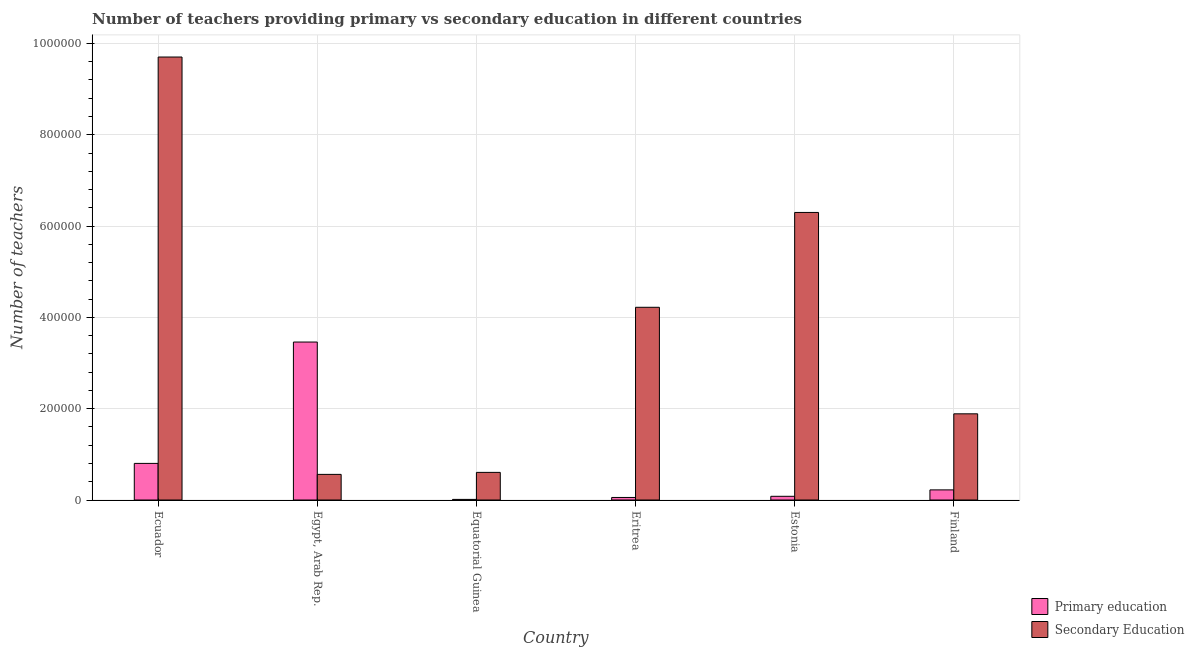How many different coloured bars are there?
Offer a very short reply. 2. How many groups of bars are there?
Keep it short and to the point. 6. How many bars are there on the 2nd tick from the left?
Your answer should be compact. 2. How many bars are there on the 6th tick from the right?
Provide a succinct answer. 2. What is the label of the 3rd group of bars from the left?
Your answer should be compact. Equatorial Guinea. What is the number of primary teachers in Finland?
Provide a succinct answer. 2.22e+04. Across all countries, what is the maximum number of primary teachers?
Provide a short and direct response. 3.46e+05. Across all countries, what is the minimum number of secondary teachers?
Provide a succinct answer. 5.61e+04. In which country was the number of secondary teachers maximum?
Give a very brief answer. Ecuador. In which country was the number of secondary teachers minimum?
Offer a very short reply. Egypt, Arab Rep. What is the total number of secondary teachers in the graph?
Provide a succinct answer. 2.33e+06. What is the difference between the number of secondary teachers in Egypt, Arab Rep. and that in Eritrea?
Give a very brief answer. -3.66e+05. What is the difference between the number of secondary teachers in Ecuador and the number of primary teachers in Equatorial Guinea?
Make the answer very short. 9.69e+05. What is the average number of primary teachers per country?
Offer a terse response. 7.72e+04. What is the difference between the number of primary teachers and number of secondary teachers in Estonia?
Your answer should be compact. -6.22e+05. In how many countries, is the number of primary teachers greater than 640000 ?
Keep it short and to the point. 0. What is the ratio of the number of primary teachers in Equatorial Guinea to that in Eritrea?
Provide a short and direct response. 0.24. Is the difference between the number of secondary teachers in Estonia and Finland greater than the difference between the number of primary teachers in Estonia and Finland?
Offer a terse response. Yes. What is the difference between the highest and the second highest number of secondary teachers?
Provide a succinct answer. 3.40e+05. What is the difference between the highest and the lowest number of primary teachers?
Make the answer very short. 3.45e+05. Is the sum of the number of secondary teachers in Equatorial Guinea and Finland greater than the maximum number of primary teachers across all countries?
Provide a short and direct response. No. What does the 1st bar from the left in Egypt, Arab Rep. represents?
Keep it short and to the point. Primary education. What is the difference between two consecutive major ticks on the Y-axis?
Your answer should be compact. 2.00e+05. Are the values on the major ticks of Y-axis written in scientific E-notation?
Provide a succinct answer. No. Where does the legend appear in the graph?
Make the answer very short. Bottom right. What is the title of the graph?
Your answer should be compact. Number of teachers providing primary vs secondary education in different countries. Does "Depositors" appear as one of the legend labels in the graph?
Provide a short and direct response. No. What is the label or title of the Y-axis?
Offer a very short reply. Number of teachers. What is the Number of teachers in Primary education in Ecuador?
Offer a terse response. 8.02e+04. What is the Number of teachers of Secondary Education in Ecuador?
Your answer should be very brief. 9.70e+05. What is the Number of teachers of Primary education in Egypt, Arab Rep.?
Provide a succinct answer. 3.46e+05. What is the Number of teachers of Secondary Education in Egypt, Arab Rep.?
Offer a very short reply. 5.61e+04. What is the Number of teachers in Primary education in Equatorial Guinea?
Your answer should be very brief. 1322. What is the Number of teachers in Secondary Education in Equatorial Guinea?
Keep it short and to the point. 6.05e+04. What is the Number of teachers in Primary education in Eritrea?
Your response must be concise. 5576. What is the Number of teachers in Secondary Education in Eritrea?
Your answer should be compact. 4.22e+05. What is the Number of teachers of Primary education in Estonia?
Provide a succinct answer. 8086. What is the Number of teachers in Secondary Education in Estonia?
Keep it short and to the point. 6.30e+05. What is the Number of teachers in Primary education in Finland?
Make the answer very short. 2.22e+04. What is the Number of teachers in Secondary Education in Finland?
Offer a very short reply. 1.89e+05. Across all countries, what is the maximum Number of teachers in Primary education?
Your answer should be compact. 3.46e+05. Across all countries, what is the maximum Number of teachers of Secondary Education?
Your answer should be very brief. 9.70e+05. Across all countries, what is the minimum Number of teachers of Primary education?
Your answer should be compact. 1322. Across all countries, what is the minimum Number of teachers in Secondary Education?
Make the answer very short. 5.61e+04. What is the total Number of teachers of Primary education in the graph?
Your answer should be very brief. 4.63e+05. What is the total Number of teachers in Secondary Education in the graph?
Your answer should be compact. 2.33e+06. What is the difference between the Number of teachers of Primary education in Ecuador and that in Egypt, Arab Rep.?
Offer a terse response. -2.66e+05. What is the difference between the Number of teachers in Secondary Education in Ecuador and that in Egypt, Arab Rep.?
Your response must be concise. 9.14e+05. What is the difference between the Number of teachers in Primary education in Ecuador and that in Equatorial Guinea?
Your answer should be compact. 7.89e+04. What is the difference between the Number of teachers of Secondary Education in Ecuador and that in Equatorial Guinea?
Provide a short and direct response. 9.10e+05. What is the difference between the Number of teachers in Primary education in Ecuador and that in Eritrea?
Offer a very short reply. 7.46e+04. What is the difference between the Number of teachers of Secondary Education in Ecuador and that in Eritrea?
Your answer should be compact. 5.48e+05. What is the difference between the Number of teachers in Primary education in Ecuador and that in Estonia?
Ensure brevity in your answer.  7.21e+04. What is the difference between the Number of teachers of Secondary Education in Ecuador and that in Estonia?
Ensure brevity in your answer.  3.40e+05. What is the difference between the Number of teachers in Primary education in Ecuador and that in Finland?
Provide a succinct answer. 5.80e+04. What is the difference between the Number of teachers in Secondary Education in Ecuador and that in Finland?
Keep it short and to the point. 7.82e+05. What is the difference between the Number of teachers in Primary education in Egypt, Arab Rep. and that in Equatorial Guinea?
Your answer should be very brief. 3.45e+05. What is the difference between the Number of teachers in Secondary Education in Egypt, Arab Rep. and that in Equatorial Guinea?
Provide a succinct answer. -4373. What is the difference between the Number of teachers in Primary education in Egypt, Arab Rep. and that in Eritrea?
Your response must be concise. 3.40e+05. What is the difference between the Number of teachers of Secondary Education in Egypt, Arab Rep. and that in Eritrea?
Offer a very short reply. -3.66e+05. What is the difference between the Number of teachers in Primary education in Egypt, Arab Rep. and that in Estonia?
Make the answer very short. 3.38e+05. What is the difference between the Number of teachers in Secondary Education in Egypt, Arab Rep. and that in Estonia?
Your answer should be compact. -5.74e+05. What is the difference between the Number of teachers of Primary education in Egypt, Arab Rep. and that in Finland?
Offer a terse response. 3.24e+05. What is the difference between the Number of teachers of Secondary Education in Egypt, Arab Rep. and that in Finland?
Your answer should be very brief. -1.33e+05. What is the difference between the Number of teachers in Primary education in Equatorial Guinea and that in Eritrea?
Provide a short and direct response. -4254. What is the difference between the Number of teachers of Secondary Education in Equatorial Guinea and that in Eritrea?
Your answer should be very brief. -3.62e+05. What is the difference between the Number of teachers in Primary education in Equatorial Guinea and that in Estonia?
Ensure brevity in your answer.  -6764. What is the difference between the Number of teachers in Secondary Education in Equatorial Guinea and that in Estonia?
Keep it short and to the point. -5.69e+05. What is the difference between the Number of teachers of Primary education in Equatorial Guinea and that in Finland?
Keep it short and to the point. -2.08e+04. What is the difference between the Number of teachers of Secondary Education in Equatorial Guinea and that in Finland?
Your response must be concise. -1.28e+05. What is the difference between the Number of teachers in Primary education in Eritrea and that in Estonia?
Provide a succinct answer. -2510. What is the difference between the Number of teachers in Secondary Education in Eritrea and that in Estonia?
Offer a very short reply. -2.08e+05. What is the difference between the Number of teachers in Primary education in Eritrea and that in Finland?
Provide a succinct answer. -1.66e+04. What is the difference between the Number of teachers in Secondary Education in Eritrea and that in Finland?
Keep it short and to the point. 2.33e+05. What is the difference between the Number of teachers in Primary education in Estonia and that in Finland?
Provide a short and direct response. -1.41e+04. What is the difference between the Number of teachers of Secondary Education in Estonia and that in Finland?
Make the answer very short. 4.41e+05. What is the difference between the Number of teachers in Primary education in Ecuador and the Number of teachers in Secondary Education in Egypt, Arab Rep.?
Keep it short and to the point. 2.40e+04. What is the difference between the Number of teachers of Primary education in Ecuador and the Number of teachers of Secondary Education in Equatorial Guinea?
Your response must be concise. 1.97e+04. What is the difference between the Number of teachers in Primary education in Ecuador and the Number of teachers in Secondary Education in Eritrea?
Your answer should be compact. -3.42e+05. What is the difference between the Number of teachers in Primary education in Ecuador and the Number of teachers in Secondary Education in Estonia?
Offer a terse response. -5.50e+05. What is the difference between the Number of teachers of Primary education in Ecuador and the Number of teachers of Secondary Education in Finland?
Give a very brief answer. -1.09e+05. What is the difference between the Number of teachers in Primary education in Egypt, Arab Rep. and the Number of teachers in Secondary Education in Equatorial Guinea?
Your response must be concise. 2.85e+05. What is the difference between the Number of teachers in Primary education in Egypt, Arab Rep. and the Number of teachers in Secondary Education in Eritrea?
Offer a very short reply. -7.61e+04. What is the difference between the Number of teachers of Primary education in Egypt, Arab Rep. and the Number of teachers of Secondary Education in Estonia?
Make the answer very short. -2.84e+05. What is the difference between the Number of teachers of Primary education in Egypt, Arab Rep. and the Number of teachers of Secondary Education in Finland?
Your answer should be very brief. 1.57e+05. What is the difference between the Number of teachers of Primary education in Equatorial Guinea and the Number of teachers of Secondary Education in Eritrea?
Make the answer very short. -4.21e+05. What is the difference between the Number of teachers in Primary education in Equatorial Guinea and the Number of teachers in Secondary Education in Estonia?
Your response must be concise. -6.29e+05. What is the difference between the Number of teachers of Primary education in Equatorial Guinea and the Number of teachers of Secondary Education in Finland?
Keep it short and to the point. -1.87e+05. What is the difference between the Number of teachers of Primary education in Eritrea and the Number of teachers of Secondary Education in Estonia?
Keep it short and to the point. -6.24e+05. What is the difference between the Number of teachers in Primary education in Eritrea and the Number of teachers in Secondary Education in Finland?
Your answer should be compact. -1.83e+05. What is the difference between the Number of teachers of Primary education in Estonia and the Number of teachers of Secondary Education in Finland?
Make the answer very short. -1.81e+05. What is the average Number of teachers of Primary education per country?
Give a very brief answer. 7.72e+04. What is the average Number of teachers of Secondary Education per country?
Offer a very short reply. 3.88e+05. What is the difference between the Number of teachers in Primary education and Number of teachers in Secondary Education in Ecuador?
Your answer should be very brief. -8.90e+05. What is the difference between the Number of teachers in Primary education and Number of teachers in Secondary Education in Egypt, Arab Rep.?
Your answer should be very brief. 2.90e+05. What is the difference between the Number of teachers in Primary education and Number of teachers in Secondary Education in Equatorial Guinea?
Offer a very short reply. -5.92e+04. What is the difference between the Number of teachers of Primary education and Number of teachers of Secondary Education in Eritrea?
Offer a terse response. -4.17e+05. What is the difference between the Number of teachers of Primary education and Number of teachers of Secondary Education in Estonia?
Provide a short and direct response. -6.22e+05. What is the difference between the Number of teachers in Primary education and Number of teachers in Secondary Education in Finland?
Make the answer very short. -1.67e+05. What is the ratio of the Number of teachers of Primary education in Ecuador to that in Egypt, Arab Rep.?
Your answer should be compact. 0.23. What is the ratio of the Number of teachers in Secondary Education in Ecuador to that in Egypt, Arab Rep.?
Give a very brief answer. 17.29. What is the ratio of the Number of teachers in Primary education in Ecuador to that in Equatorial Guinea?
Provide a succinct answer. 60.65. What is the ratio of the Number of teachers of Secondary Education in Ecuador to that in Equatorial Guinea?
Keep it short and to the point. 16.04. What is the ratio of the Number of teachers in Primary education in Ecuador to that in Eritrea?
Your answer should be very brief. 14.38. What is the ratio of the Number of teachers of Secondary Education in Ecuador to that in Eritrea?
Offer a terse response. 2.3. What is the ratio of the Number of teachers in Primary education in Ecuador to that in Estonia?
Offer a very short reply. 9.92. What is the ratio of the Number of teachers in Secondary Education in Ecuador to that in Estonia?
Give a very brief answer. 1.54. What is the ratio of the Number of teachers in Primary education in Ecuador to that in Finland?
Your answer should be compact. 3.62. What is the ratio of the Number of teachers of Secondary Education in Ecuador to that in Finland?
Make the answer very short. 5.14. What is the ratio of the Number of teachers in Primary education in Egypt, Arab Rep. to that in Equatorial Guinea?
Provide a succinct answer. 261.71. What is the ratio of the Number of teachers of Secondary Education in Egypt, Arab Rep. to that in Equatorial Guinea?
Make the answer very short. 0.93. What is the ratio of the Number of teachers in Primary education in Egypt, Arab Rep. to that in Eritrea?
Your answer should be very brief. 62.05. What is the ratio of the Number of teachers in Secondary Education in Egypt, Arab Rep. to that in Eritrea?
Your response must be concise. 0.13. What is the ratio of the Number of teachers in Primary education in Egypt, Arab Rep. to that in Estonia?
Offer a very short reply. 42.79. What is the ratio of the Number of teachers in Secondary Education in Egypt, Arab Rep. to that in Estonia?
Your answer should be very brief. 0.09. What is the ratio of the Number of teachers in Primary education in Egypt, Arab Rep. to that in Finland?
Your response must be concise. 15.61. What is the ratio of the Number of teachers in Secondary Education in Egypt, Arab Rep. to that in Finland?
Keep it short and to the point. 0.3. What is the ratio of the Number of teachers in Primary education in Equatorial Guinea to that in Eritrea?
Offer a terse response. 0.24. What is the ratio of the Number of teachers of Secondary Education in Equatorial Guinea to that in Eritrea?
Offer a very short reply. 0.14. What is the ratio of the Number of teachers of Primary education in Equatorial Guinea to that in Estonia?
Offer a very short reply. 0.16. What is the ratio of the Number of teachers of Secondary Education in Equatorial Guinea to that in Estonia?
Give a very brief answer. 0.1. What is the ratio of the Number of teachers in Primary education in Equatorial Guinea to that in Finland?
Keep it short and to the point. 0.06. What is the ratio of the Number of teachers in Secondary Education in Equatorial Guinea to that in Finland?
Your response must be concise. 0.32. What is the ratio of the Number of teachers in Primary education in Eritrea to that in Estonia?
Make the answer very short. 0.69. What is the ratio of the Number of teachers in Secondary Education in Eritrea to that in Estonia?
Provide a short and direct response. 0.67. What is the ratio of the Number of teachers of Primary education in Eritrea to that in Finland?
Your answer should be very brief. 0.25. What is the ratio of the Number of teachers in Secondary Education in Eritrea to that in Finland?
Provide a succinct answer. 2.24. What is the ratio of the Number of teachers of Primary education in Estonia to that in Finland?
Your answer should be very brief. 0.36. What is the ratio of the Number of teachers of Secondary Education in Estonia to that in Finland?
Make the answer very short. 3.34. What is the difference between the highest and the second highest Number of teachers in Primary education?
Give a very brief answer. 2.66e+05. What is the difference between the highest and the second highest Number of teachers in Secondary Education?
Ensure brevity in your answer.  3.40e+05. What is the difference between the highest and the lowest Number of teachers in Primary education?
Ensure brevity in your answer.  3.45e+05. What is the difference between the highest and the lowest Number of teachers of Secondary Education?
Your answer should be very brief. 9.14e+05. 